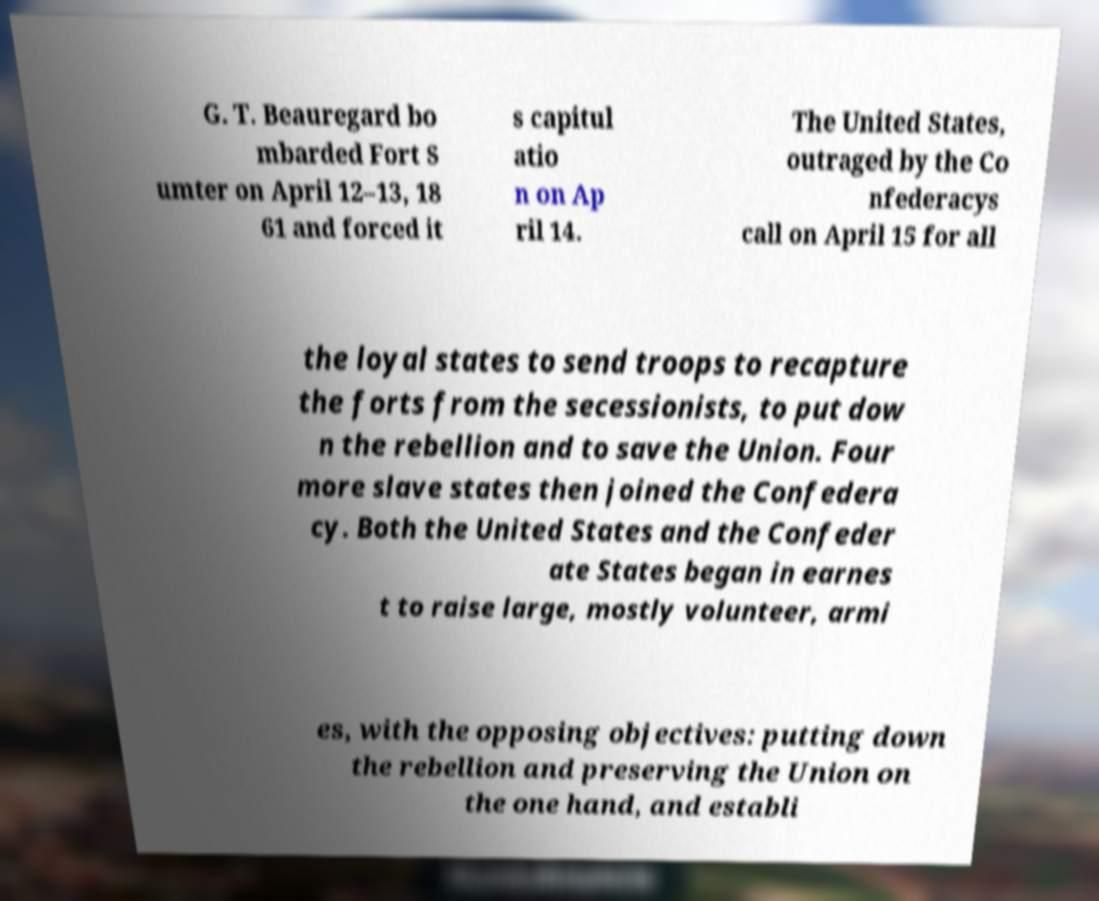Can you read and provide the text displayed in the image?This photo seems to have some interesting text. Can you extract and type it out for me? G. T. Beauregard bo mbarded Fort S umter on April 12–13, 18 61 and forced it s capitul atio n on Ap ril 14. The United States, outraged by the Co nfederacys call on April 15 for all the loyal states to send troops to recapture the forts from the secessionists, to put dow n the rebellion and to save the Union. Four more slave states then joined the Confedera cy. Both the United States and the Confeder ate States began in earnes t to raise large, mostly volunteer, armi es, with the opposing objectives: putting down the rebellion and preserving the Union on the one hand, and establi 